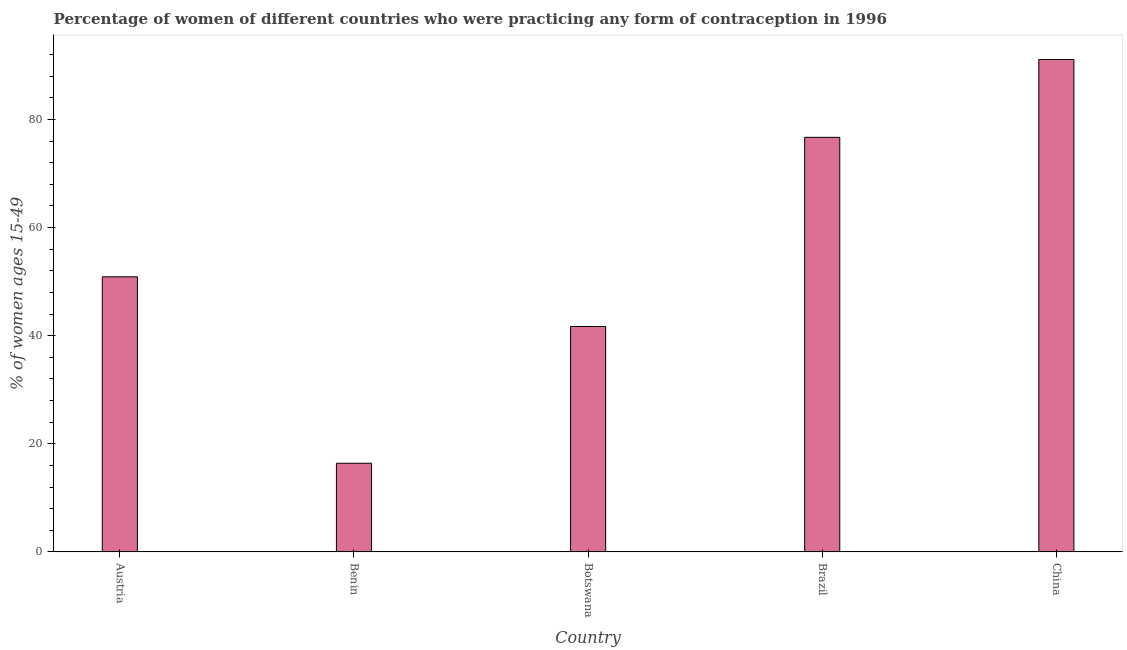Does the graph contain grids?
Give a very brief answer. No. What is the title of the graph?
Your answer should be very brief. Percentage of women of different countries who were practicing any form of contraception in 1996. What is the label or title of the X-axis?
Your answer should be compact. Country. What is the label or title of the Y-axis?
Make the answer very short. % of women ages 15-49. What is the contraceptive prevalence in Botswana?
Your answer should be very brief. 41.7. Across all countries, what is the maximum contraceptive prevalence?
Provide a short and direct response. 91.1. In which country was the contraceptive prevalence maximum?
Your answer should be compact. China. In which country was the contraceptive prevalence minimum?
Provide a short and direct response. Benin. What is the sum of the contraceptive prevalence?
Make the answer very short. 276.8. What is the difference between the contraceptive prevalence in Benin and Brazil?
Ensure brevity in your answer.  -60.3. What is the average contraceptive prevalence per country?
Offer a very short reply. 55.36. What is the median contraceptive prevalence?
Provide a succinct answer. 50.9. What is the ratio of the contraceptive prevalence in Austria to that in China?
Give a very brief answer. 0.56. Is the difference between the contraceptive prevalence in Austria and Benin greater than the difference between any two countries?
Your response must be concise. No. What is the difference between the highest and the second highest contraceptive prevalence?
Provide a short and direct response. 14.4. What is the difference between the highest and the lowest contraceptive prevalence?
Ensure brevity in your answer.  74.7. Are all the bars in the graph horizontal?
Ensure brevity in your answer.  No. How many countries are there in the graph?
Ensure brevity in your answer.  5. What is the difference between two consecutive major ticks on the Y-axis?
Provide a short and direct response. 20. Are the values on the major ticks of Y-axis written in scientific E-notation?
Your response must be concise. No. What is the % of women ages 15-49 of Austria?
Your answer should be compact. 50.9. What is the % of women ages 15-49 of Benin?
Your answer should be compact. 16.4. What is the % of women ages 15-49 in Botswana?
Offer a very short reply. 41.7. What is the % of women ages 15-49 in Brazil?
Offer a terse response. 76.7. What is the % of women ages 15-49 of China?
Your answer should be compact. 91.1. What is the difference between the % of women ages 15-49 in Austria and Benin?
Give a very brief answer. 34.5. What is the difference between the % of women ages 15-49 in Austria and Brazil?
Your answer should be very brief. -25.8. What is the difference between the % of women ages 15-49 in Austria and China?
Make the answer very short. -40.2. What is the difference between the % of women ages 15-49 in Benin and Botswana?
Make the answer very short. -25.3. What is the difference between the % of women ages 15-49 in Benin and Brazil?
Your answer should be very brief. -60.3. What is the difference between the % of women ages 15-49 in Benin and China?
Your response must be concise. -74.7. What is the difference between the % of women ages 15-49 in Botswana and Brazil?
Ensure brevity in your answer.  -35. What is the difference between the % of women ages 15-49 in Botswana and China?
Your answer should be compact. -49.4. What is the difference between the % of women ages 15-49 in Brazil and China?
Offer a very short reply. -14.4. What is the ratio of the % of women ages 15-49 in Austria to that in Benin?
Your answer should be very brief. 3.1. What is the ratio of the % of women ages 15-49 in Austria to that in Botswana?
Offer a terse response. 1.22. What is the ratio of the % of women ages 15-49 in Austria to that in Brazil?
Make the answer very short. 0.66. What is the ratio of the % of women ages 15-49 in Austria to that in China?
Offer a very short reply. 0.56. What is the ratio of the % of women ages 15-49 in Benin to that in Botswana?
Your answer should be compact. 0.39. What is the ratio of the % of women ages 15-49 in Benin to that in Brazil?
Make the answer very short. 0.21. What is the ratio of the % of women ages 15-49 in Benin to that in China?
Your answer should be very brief. 0.18. What is the ratio of the % of women ages 15-49 in Botswana to that in Brazil?
Provide a succinct answer. 0.54. What is the ratio of the % of women ages 15-49 in Botswana to that in China?
Ensure brevity in your answer.  0.46. What is the ratio of the % of women ages 15-49 in Brazil to that in China?
Make the answer very short. 0.84. 